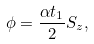Convert formula to latex. <formula><loc_0><loc_0><loc_500><loc_500>\phi = \frac { \alpha t _ { 1 } } { 2 } S _ { z } ,</formula> 